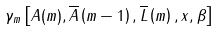<formula> <loc_0><loc_0><loc_500><loc_500>\gamma _ { m } \left [ A ( m ) , \overline { A } \left ( m - 1 \right ) , \overline { L } \left ( m \right ) , x , \beta \right ]</formula> 